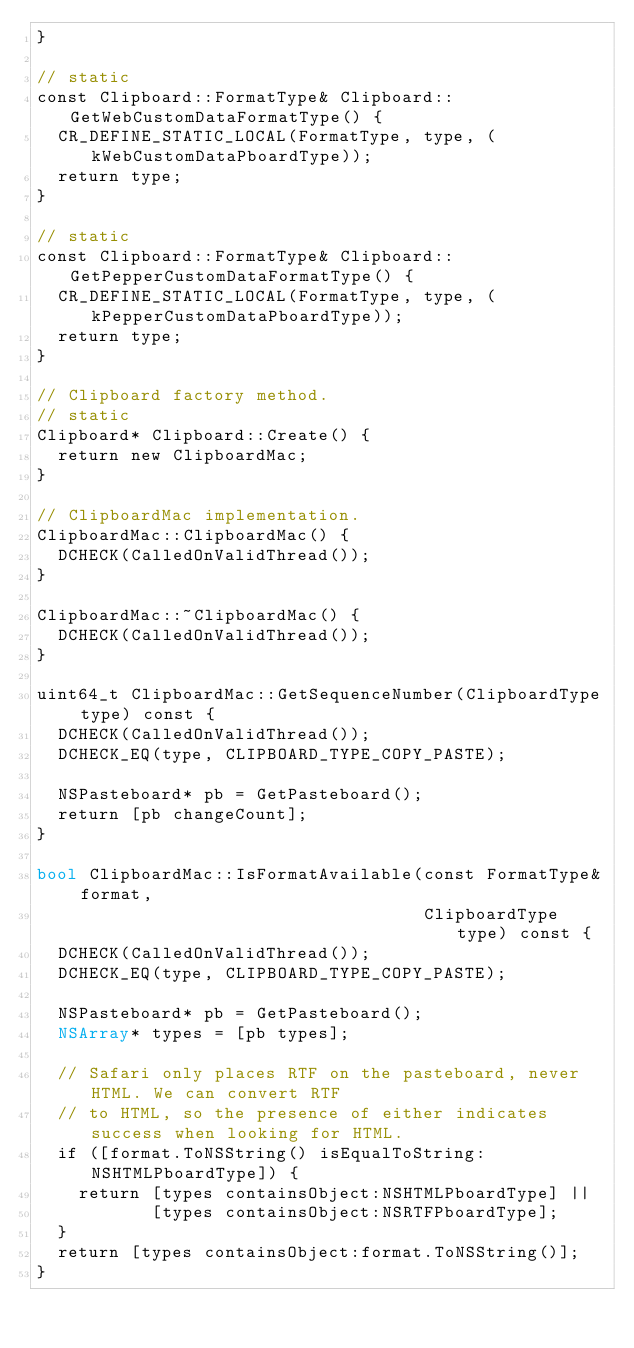Convert code to text. <code><loc_0><loc_0><loc_500><loc_500><_ObjectiveC_>}

// static
const Clipboard::FormatType& Clipboard::GetWebCustomDataFormatType() {
  CR_DEFINE_STATIC_LOCAL(FormatType, type, (kWebCustomDataPboardType));
  return type;
}

// static
const Clipboard::FormatType& Clipboard::GetPepperCustomDataFormatType() {
  CR_DEFINE_STATIC_LOCAL(FormatType, type, (kPepperCustomDataPboardType));
  return type;
}

// Clipboard factory method.
// static
Clipboard* Clipboard::Create() {
  return new ClipboardMac;
}

// ClipboardMac implementation.
ClipboardMac::ClipboardMac() {
  DCHECK(CalledOnValidThread());
}

ClipboardMac::~ClipboardMac() {
  DCHECK(CalledOnValidThread());
}

uint64_t ClipboardMac::GetSequenceNumber(ClipboardType type) const {
  DCHECK(CalledOnValidThread());
  DCHECK_EQ(type, CLIPBOARD_TYPE_COPY_PASTE);

  NSPasteboard* pb = GetPasteboard();
  return [pb changeCount];
}

bool ClipboardMac::IsFormatAvailable(const FormatType& format,
                                     ClipboardType type) const {
  DCHECK(CalledOnValidThread());
  DCHECK_EQ(type, CLIPBOARD_TYPE_COPY_PASTE);

  NSPasteboard* pb = GetPasteboard();
  NSArray* types = [pb types];

  // Safari only places RTF on the pasteboard, never HTML. We can convert RTF
  // to HTML, so the presence of either indicates success when looking for HTML.
  if ([format.ToNSString() isEqualToString:NSHTMLPboardType]) {
    return [types containsObject:NSHTMLPboardType] ||
           [types containsObject:NSRTFPboardType];
  }
  return [types containsObject:format.ToNSString()];
}
</code> 